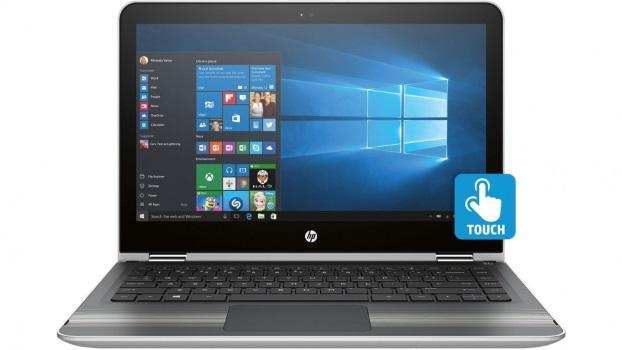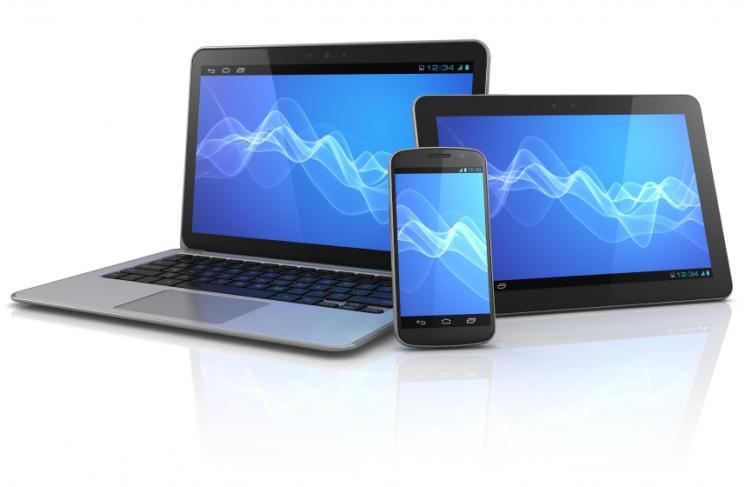The first image is the image on the left, the second image is the image on the right. Assess this claim about the two images: "The right image includes a greater number of devices than the left image.". Correct or not? Answer yes or no. Yes. 